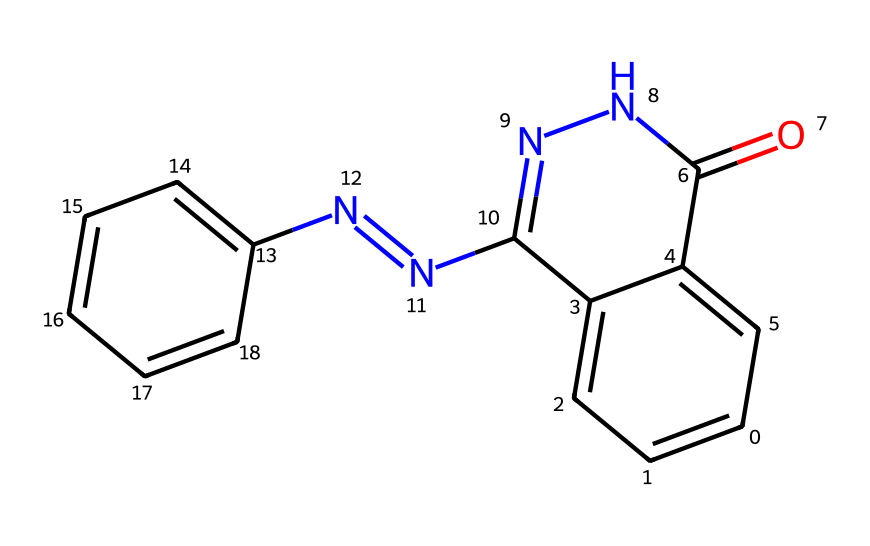What is the molecular formula of this compound? To find the molecular formula, count all the atoms present in the chemical structure. The breakdown is: 13 Carbon (C), 10 Hydrogen (H), 4 Nitrogen (N), and 2 Oxygen (O). Therefore, the molecular formula is C13H10N4O2.
Answer: C13H10N4O2 How many rings are present in the structure? By analyzing the chemical structure, we can identify that there are two fused rings present, which facilitate the unique luminescent properties of luminol.
Answer: two What type of functional group is prominently featured in this chemical? In the chemical structure, there is a carbonyl (C=O) functional group, specifically characteristic of ketones. This group is crucial for the compound's reactivity.
Answer: carbonyl Does this molecule contain any nitrogen atoms? Counting the visible nitrogen atoms in the structure, there are four nitrogen atoms present, contributing to the compound's unique properties.
Answer: four What characteristic does the carbonyl group impart to luminol? The presence of the carbonyl group (C=O) is responsible for the ketone nature of luminol, affecting its reactivity and interaction with other molecules in chemiluminescent reactions.
Answer: reactivity What is the significance of the fused ring structure in luminol? The fused ring structure increases the stability of the molecule and is important for the efficient light emission during the chemiluminescent reaction. This structural characteristic enables luminol to glow brightly.
Answer: stability 